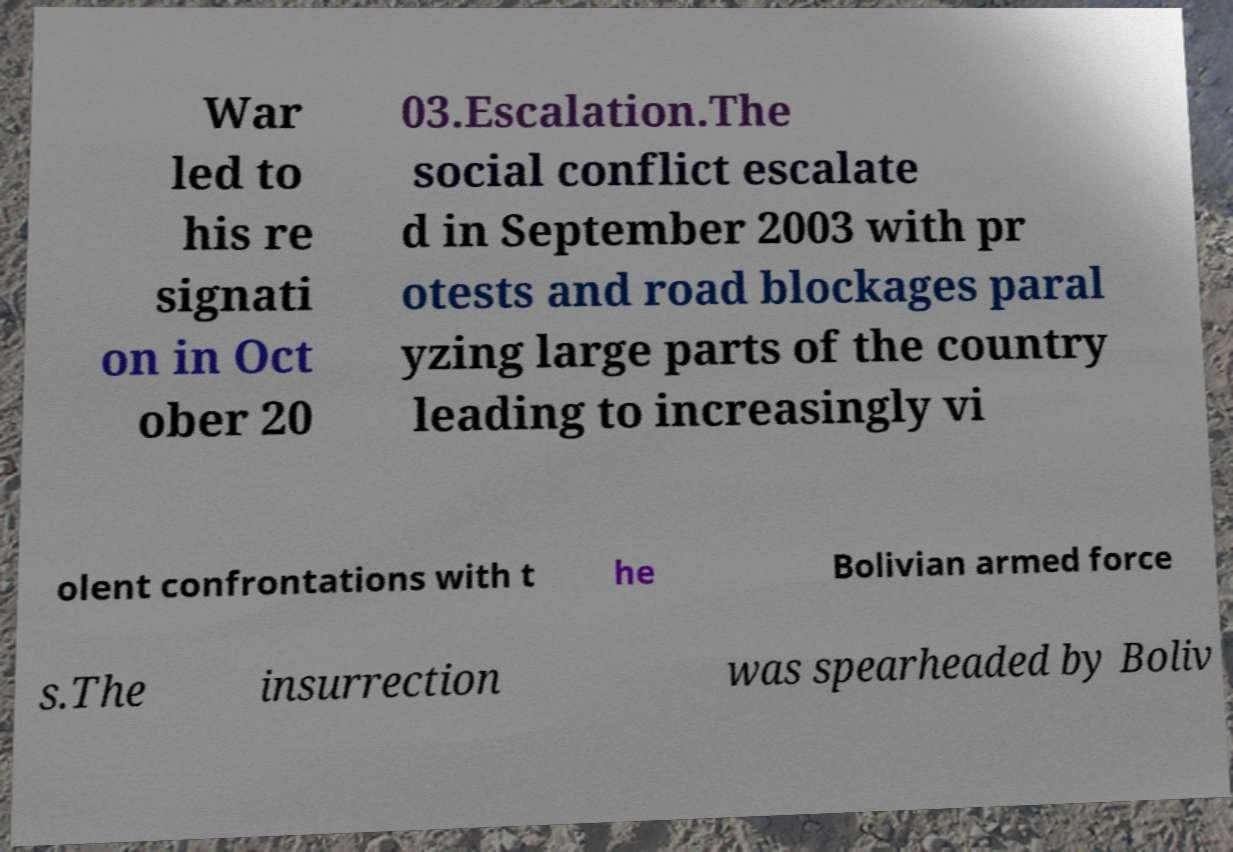What messages or text are displayed in this image? I need them in a readable, typed format. War led to his re signati on in Oct ober 20 03.Escalation.The social conflict escalate d in September 2003 with pr otests and road blockages paral yzing large parts of the country leading to increasingly vi olent confrontations with t he Bolivian armed force s.The insurrection was spearheaded by Boliv 